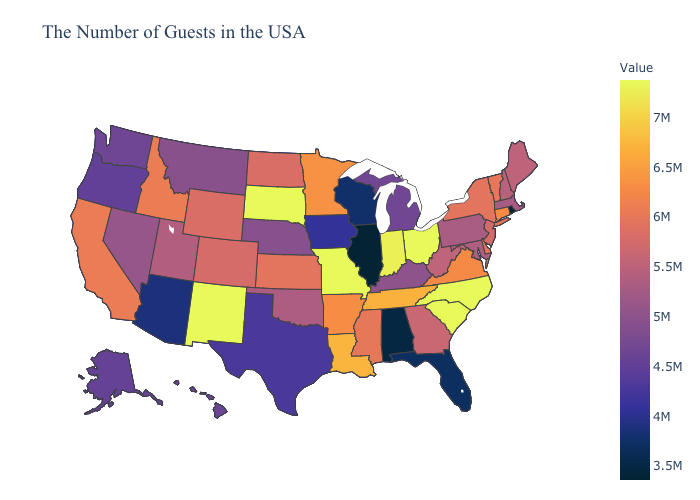Among the states that border Louisiana , does Texas have the highest value?
Quick response, please. No. Among the states that border Maine , which have the lowest value?
Be succinct. New Hampshire. Does New Mexico have the highest value in the West?
Be succinct. Yes. Does New Mexico have the highest value in the West?
Keep it brief. Yes. Does Connecticut have the highest value in the Northeast?
Short answer required. Yes. 